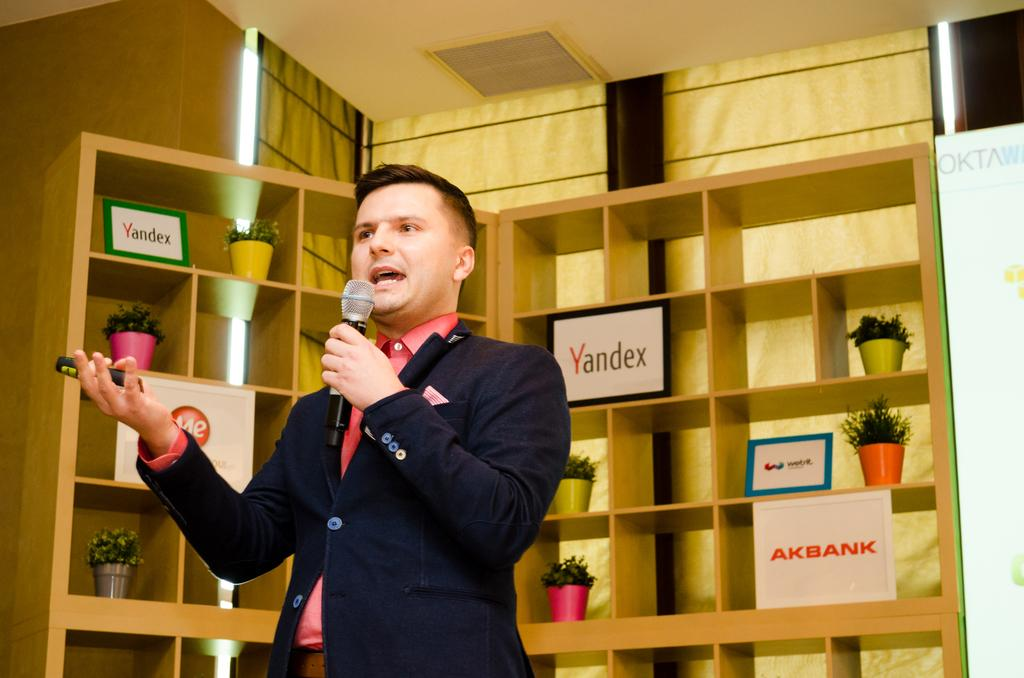What is the person in the image holding? The person is holding a mic. What can be seen in the background of the image? There are houseplants, name frames, shelves, and some objects visible in the background. What type of structure is visible in the background of the image? There is a wall and a roof visible in the background, which suggests an indoor setting. What type of frog can be seen sitting on the shelf in the image? There is no frog present in the image; only houseplants, name frames, shelves, and other objects are visible on the shelves. What day of the week is the person performing on in the image? The day of the week is not mentioned or visible in the image, so it cannot be determined. 